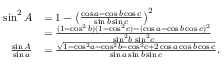<formula> <loc_0><loc_0><loc_500><loc_500>{ \begin{array} { r l } { \sin ^ { 2 } A } & { = 1 - \left ( { \frac { \cos a - \cos b \cos c } { \sin b \sin c } } \right ) ^ { 2 } } \\ & { = { \frac { ( 1 - \cos ^ { 2 } b ) ( 1 - \cos ^ { 2 } c ) - ( \cos a - \cos b \cos c ) ^ { 2 } } { \sin ^ { 2 } \, b \, \sin ^ { 2 } \, c } } } \\ { { \frac { \sin A } { \sin a } } } & { = { \frac { \sqrt { 1 - \cos ^ { 2 } \, a - \cos ^ { 2 } \, b - \cos ^ { 2 } \, c + 2 \cos a \cos b \cos c } } { \sin a \sin b \sin c } } . } \end{array} }</formula> 